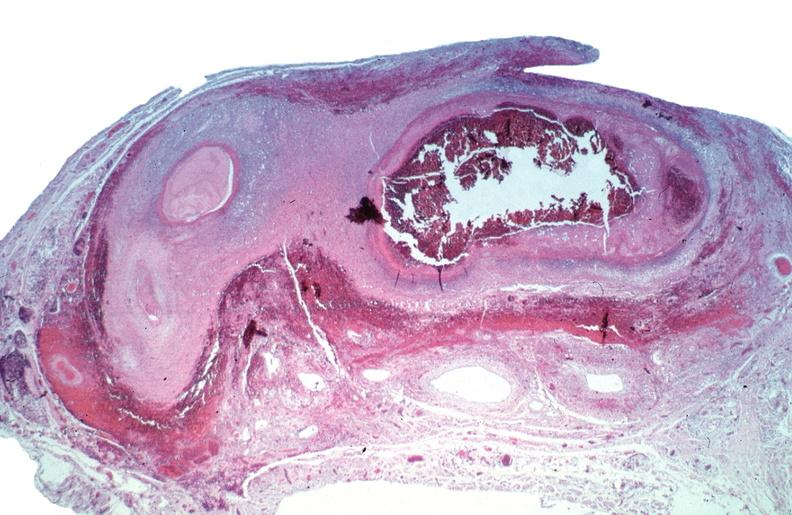s cardiovascular present?
Answer the question using a single word or phrase. Yes 